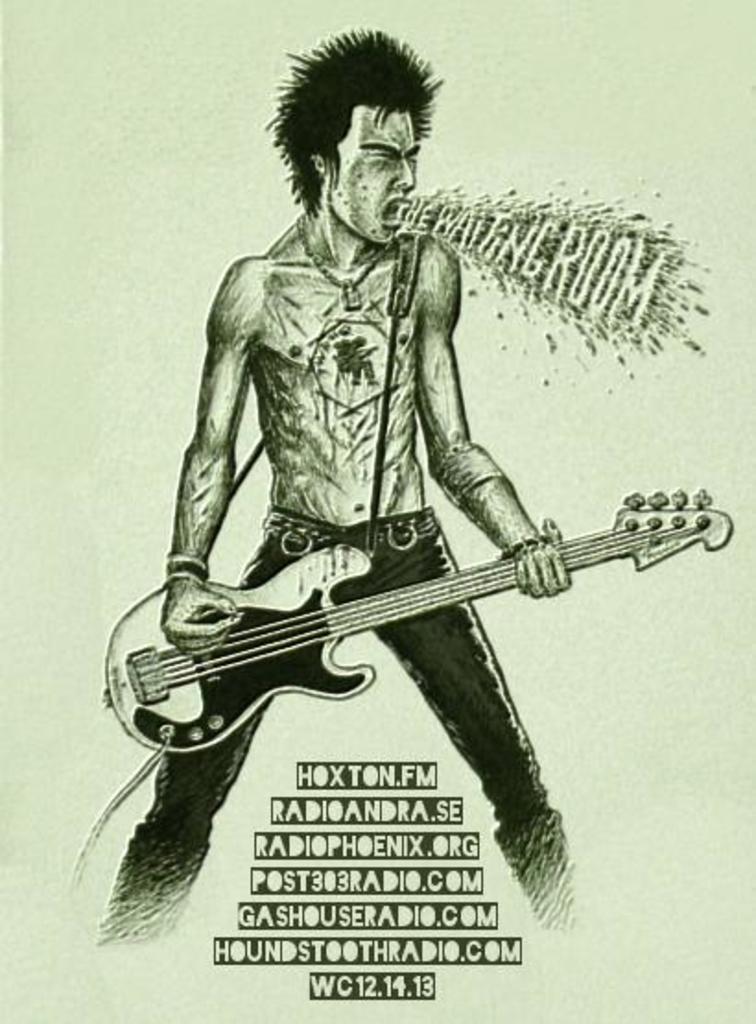Could you give a brief overview of what you see in this image? In this image I can see a depiction picture of a man. I can also see he is holding a guitar. On the right side and on the bottom side of the image, I can see something is written. 